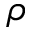Convert formula to latex. <formula><loc_0><loc_0><loc_500><loc_500>\rho</formula> 